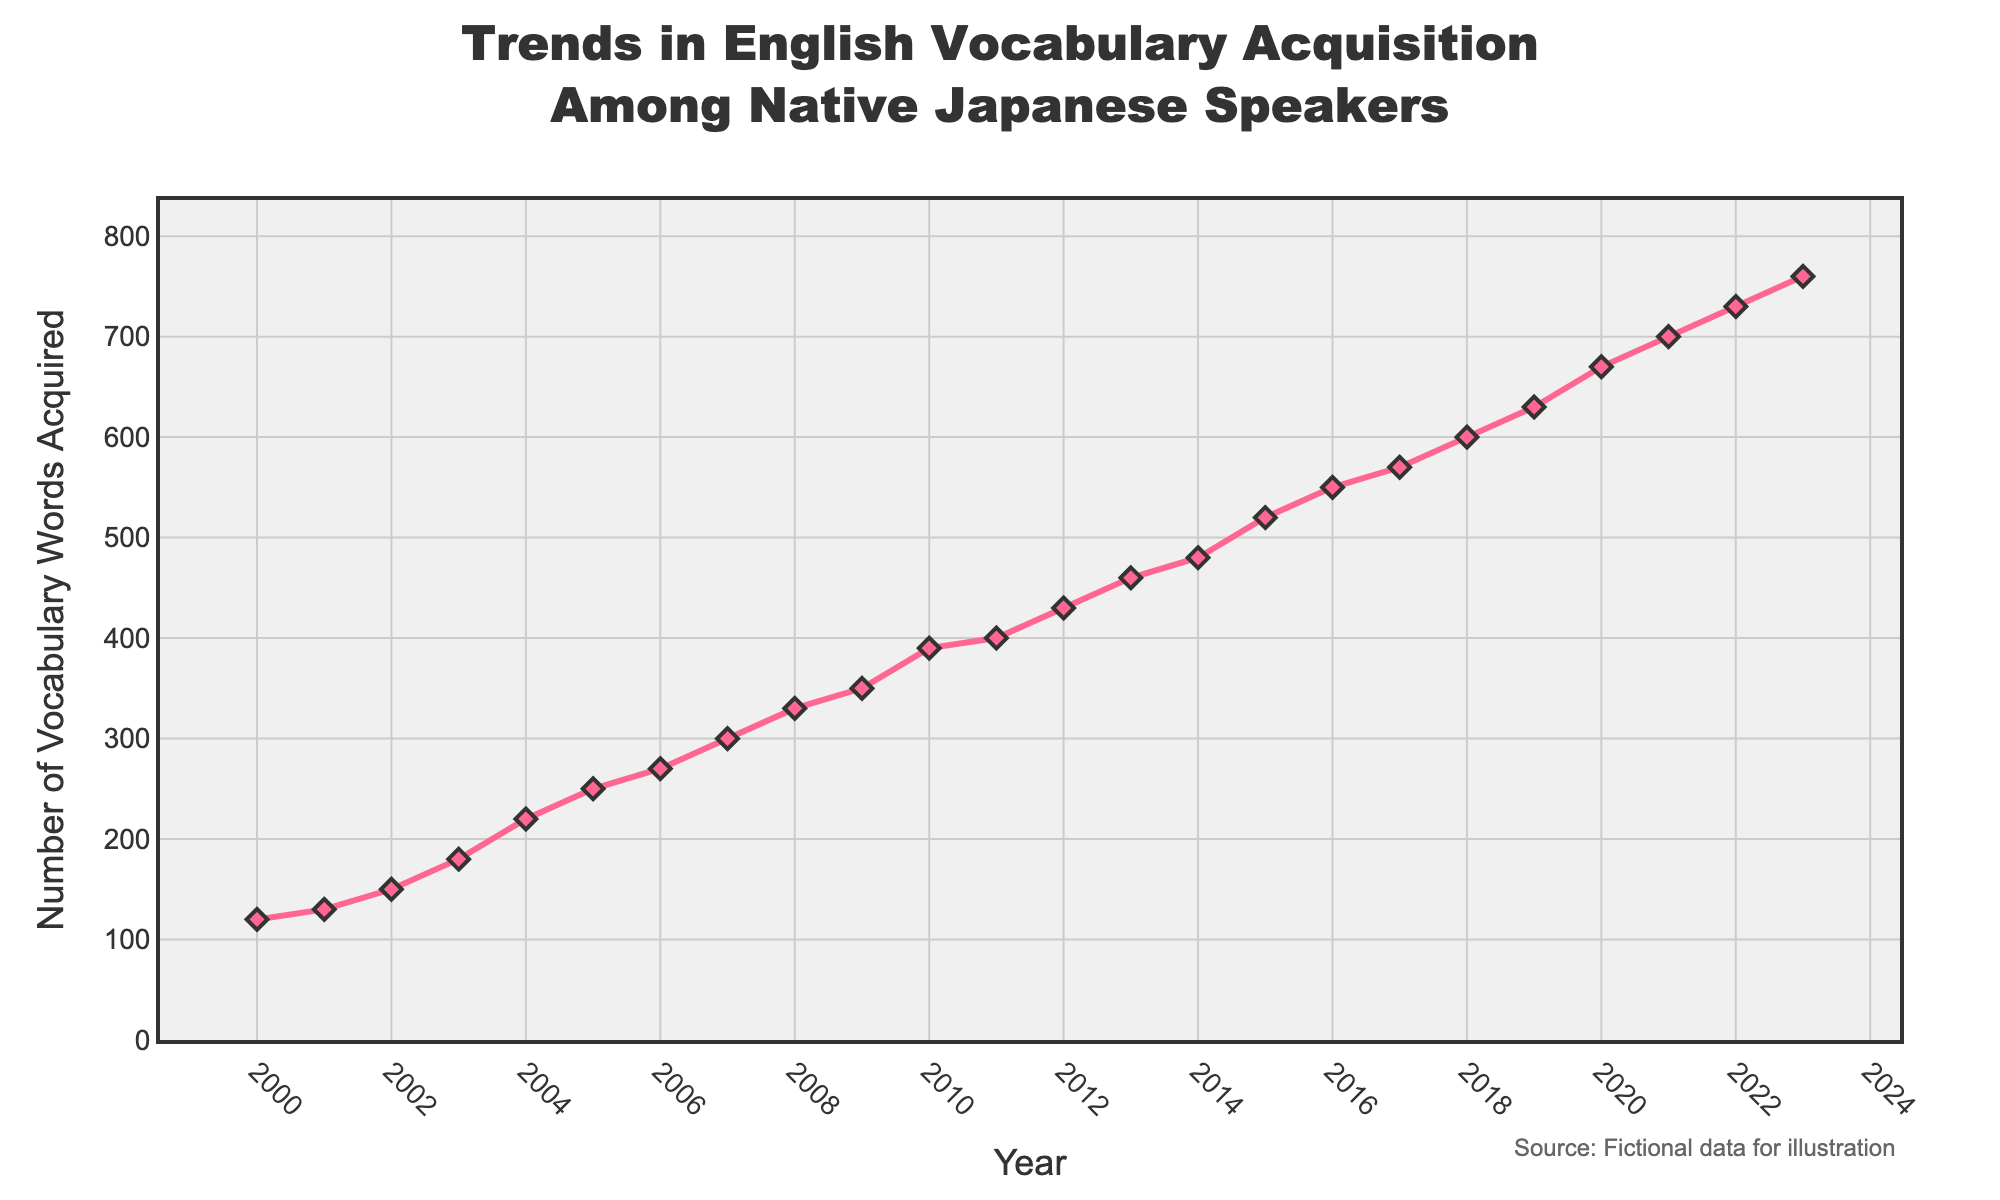What is the title of the figure? The title is usually displayed at the top of the plot. It provides a quick summary of what the plot is about. In this case, the title is "Trends in English Vocabulary Acquisition Among Native Japanese Speakers".
Answer: Trends in English Vocabulary Acquisition Among Native Japanese Speakers What is the number of vocabulary words acquired in 2010? Look for the year 2010 on the x-axis and check the corresponding y-axis value. In the year 2010, the number of vocabulary words acquired is 390.
Answer: 390 How many years does the plot cover? Count the number of unique years shown on the x-axis. The plot starts at 2000 and ends at 2023, so it covers 24 years.
Answer: 24 What was the increase in the number of vocabulary words acquired from 2005 to 2010? Find the y-axis values for both years (2005 = 250, 2010 = 390) and subtract the former from the latter. The increase is 390 - 250 = 140.
Answer: 140 Which year showed the highest number of vocabulary words acquired? Look for the highest point in the plot, where the y-axis value is the greatest. The highest number of vocabulary words acquired is in 2023, with 760 words.
Answer: 2023 What is the average number of vocabulary words acquired between 2000 and 2010? Sum the y-axis values from 2000 to 2010 and divide by the number of years (11). The total is 390 + 350 + 330 + 300 + 270 + 250 + 220 + 180 + 150 + 130 + 120 = 2690, and the average is 2690 / 11 = 244.5.
Answer: 244.5 Which year experienced the largest growth in vocabulary words acquired compared to the previous year? Calculate the year-to-year difference for each pair of subsequent years and find the maximum. The largest increase is from 2003 to 2004 (220 - 180 = 40).
Answer: 2004 What is the overall trend in vocabulary acquisition from 2000 to 2023? Observe the general direction of the plot. The overall trend shows a steady increase in the number of vocabulary words acquired over the years.
Answer: Increasing How many data points are shown in the figure? Count the markers (diamonds) on the line plot. Each marker represents a data point for each year. There are 24 data points from 2000 to 2023.
Answer: 24 Compare the number of vocabulary words acquired in 2015 and 2020. Which year had more? Find the y-axis values for both years (2015 = 520, 2020 = 670) and compare them. The year 2020 had more vocabulary words acquired.
Answer: 2020 